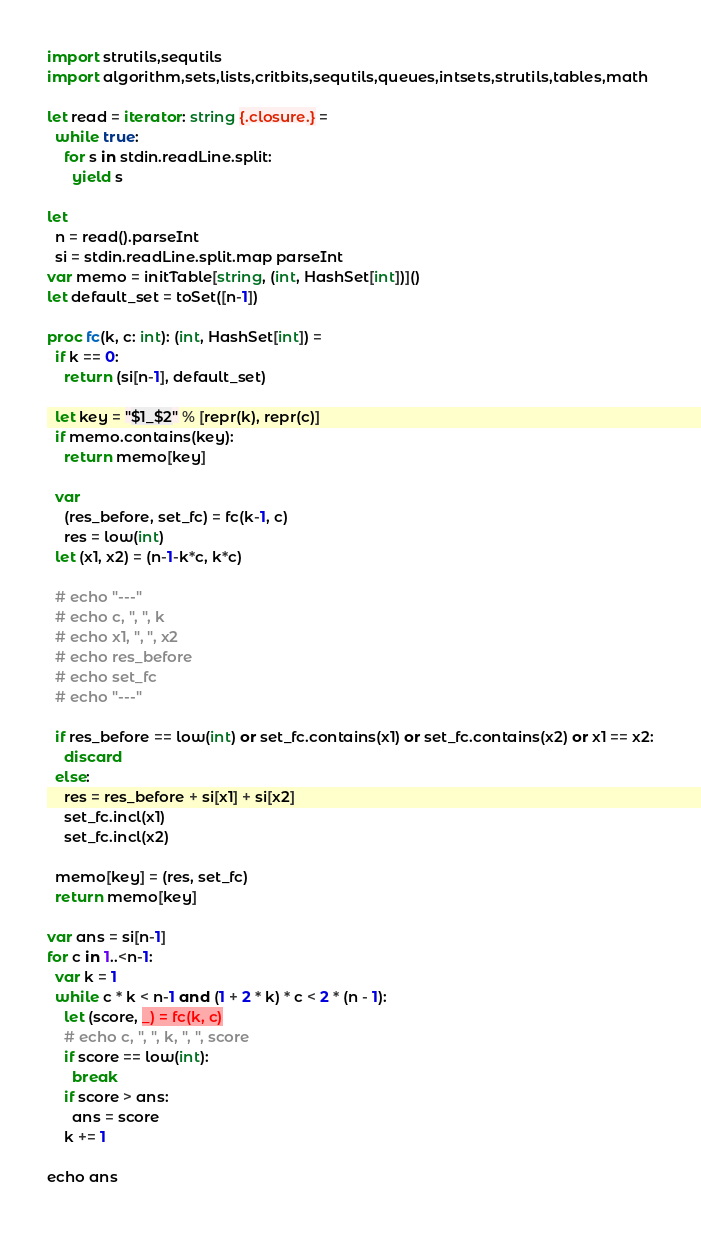Convert code to text. <code><loc_0><loc_0><loc_500><loc_500><_Nim_>import strutils,sequtils
import algorithm,sets,lists,critbits,sequtils,queues,intsets,strutils,tables,math

let read = iterator: string {.closure.} =
  while true:
    for s in stdin.readLine.split:
      yield s

let
  n = read().parseInt
  si = stdin.readLine.split.map parseInt
var memo = initTable[string, (int, HashSet[int])]()
let default_set = toSet([n-1])

proc fc(k, c: int): (int, HashSet[int]) =
  if k == 0:
    return (si[n-1], default_set)
  
  let key = "$1_$2" % [repr(k), repr(c)]
  if memo.contains(key):
    return memo[key]
  
  var
    (res_before, set_fc) = fc(k-1, c)
    res = low(int)
  let (x1, x2) = (n-1-k*c, k*c)

  # echo "---"
  # echo c, ", ", k
  # echo x1, ", ", x2
  # echo res_before
  # echo set_fc
  # echo "---"
  
  if res_before == low(int) or set_fc.contains(x1) or set_fc.contains(x2) or x1 == x2:
    discard
  else:
    res = res_before + si[x1] + si[x2]
    set_fc.incl(x1)
    set_fc.incl(x2)

  memo[key] = (res, set_fc)
  return memo[key]

var ans = si[n-1]
for c in 1..<n-1:
  var k = 1
  while c * k < n-1 and (1 + 2 * k) * c < 2 * (n - 1):
    let (score, _) = fc(k, c)
    # echo c, ", ", k, ", ", score
    if score == low(int):
      break
    if score > ans:
      ans = score
    k += 1

echo ans
</code> 